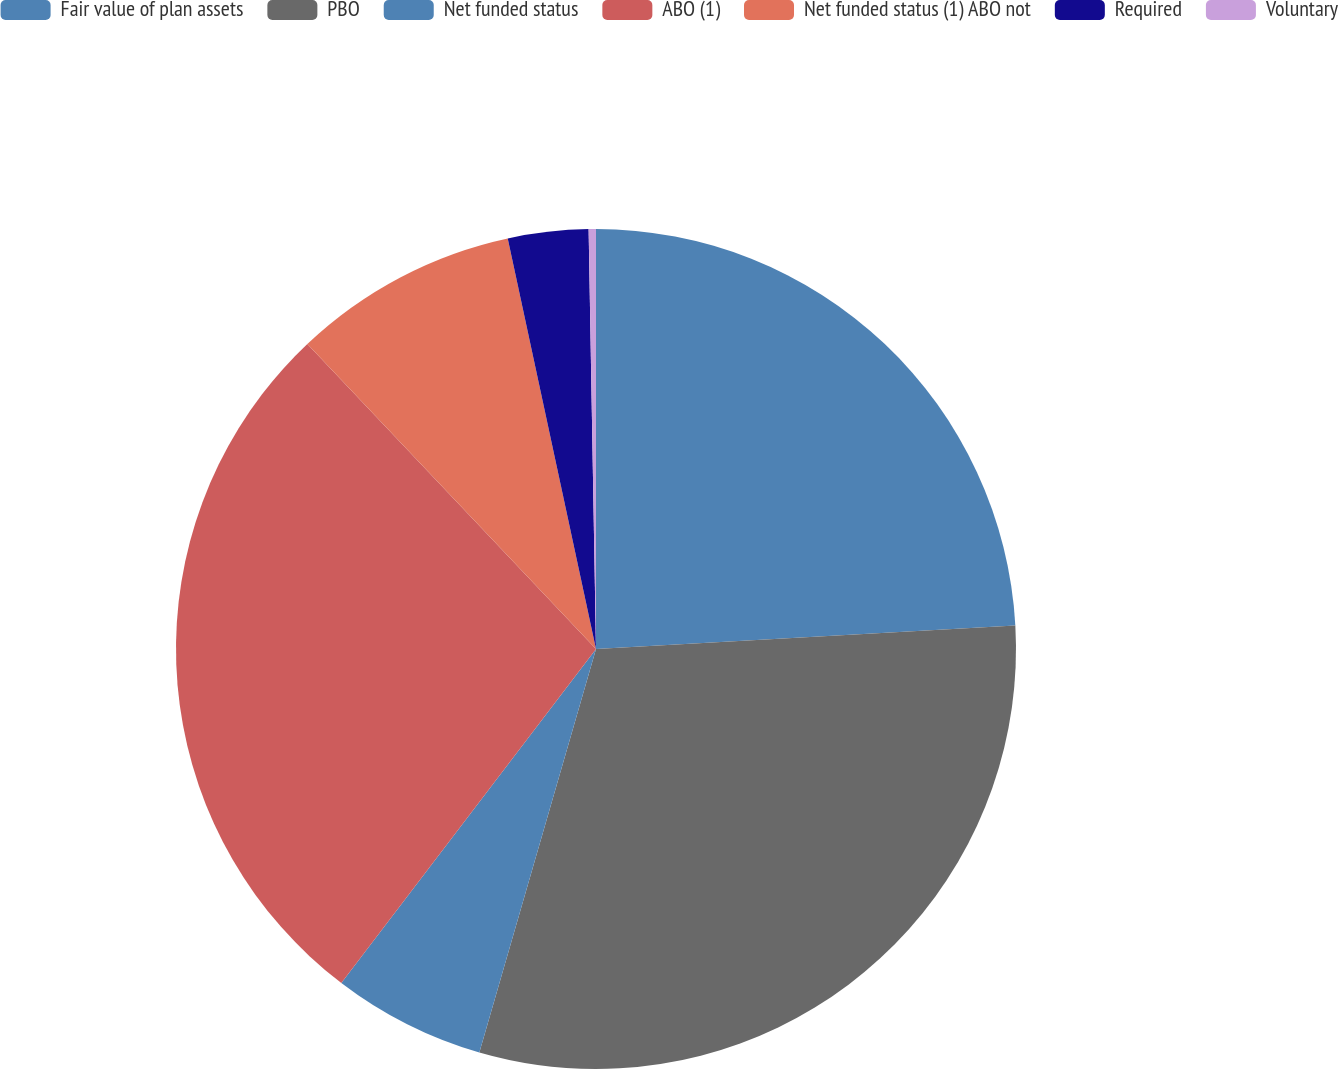<chart> <loc_0><loc_0><loc_500><loc_500><pie_chart><fcel>Fair value of plan assets<fcel>PBO<fcel>Net funded status<fcel>ABO (1)<fcel>Net funded status (1) ABO not<fcel>Required<fcel>Voluntary<nl><fcel>24.11%<fcel>30.37%<fcel>5.89%<fcel>27.57%<fcel>8.69%<fcel>3.09%<fcel>0.28%<nl></chart> 